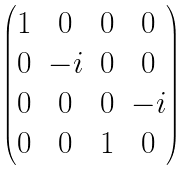<formula> <loc_0><loc_0><loc_500><loc_500>\begin{pmatrix} 1 & 0 & 0 & 0 \\ 0 & - i & 0 & 0 \\ 0 & 0 & 0 & - i \\ 0 & 0 & 1 & 0 \\ \end{pmatrix}</formula> 